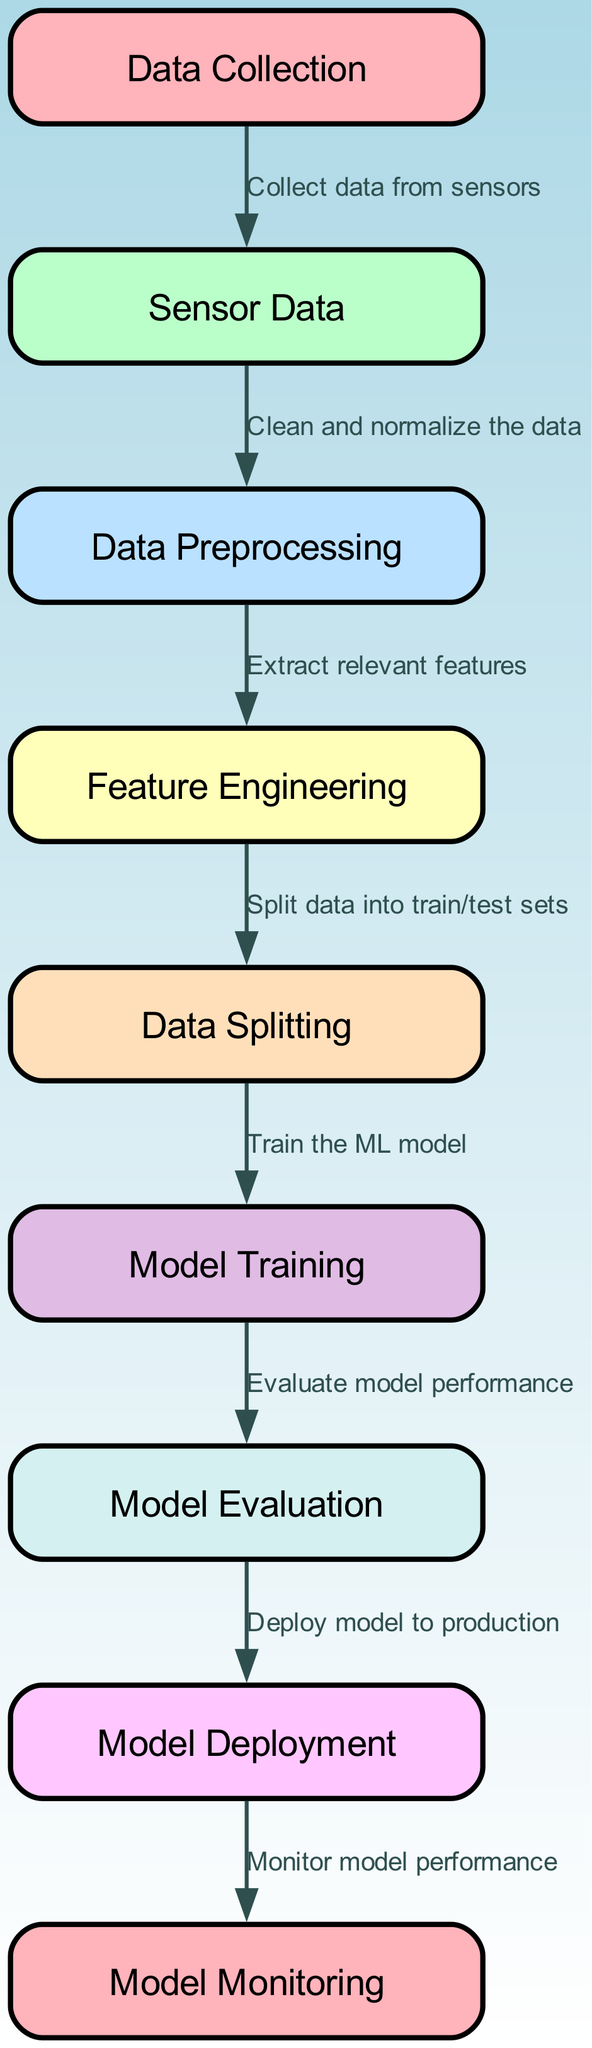What is the first step in the diagram? The first node in the diagram is "Data Collection," which is where the process begins.
Answer: Data Collection How many edges are there in total in the diagram? Counting all directed connections between nodes, there are 8 edges connecting various stages of the process in the diagram.
Answer: 8 Which node follows "Feature Engineering"? After "Feature Engineering," the next node is "Data Splitting," as shown by the directed flow from one to the other.
Answer: Data Splitting What is the purpose of the "Model Evaluation" node? The "Model Evaluation" node is where the performance of the trained model is assessed before moving to deployment, indicated by its connection to "Model Training."
Answer: Evaluate model performance How does the process flow from "Deployment"? Following "Deployment," the next step in the diagram is "Monitoring," indicating that once the model is deployed, its performance is monitored.
Answer: Model Monitoring Which node collects data from sensors? The "Data Collection" node is responsible for collecting data from sensors, as indicated by its description in the diagram.
Answer: Data Collection What comes after "Model Training"? The next step following "Model Training" is "Model Evaluation," as the diagram shows that training should be followed by evaluating how well the model performs.
Answer: Model Evaluation What is the last step shown in the diagram? The last node in the diagram is "Model Monitoring," which indicates that the final stage involves ongoing performance tracking of the deployed model.
Answer: Model Monitoring How many main nodes represent different stages of the predictive maintenance process? There are a total of 9 main nodes represented in the diagram that each depict a different stage in the predictive maintenance process.
Answer: 9 